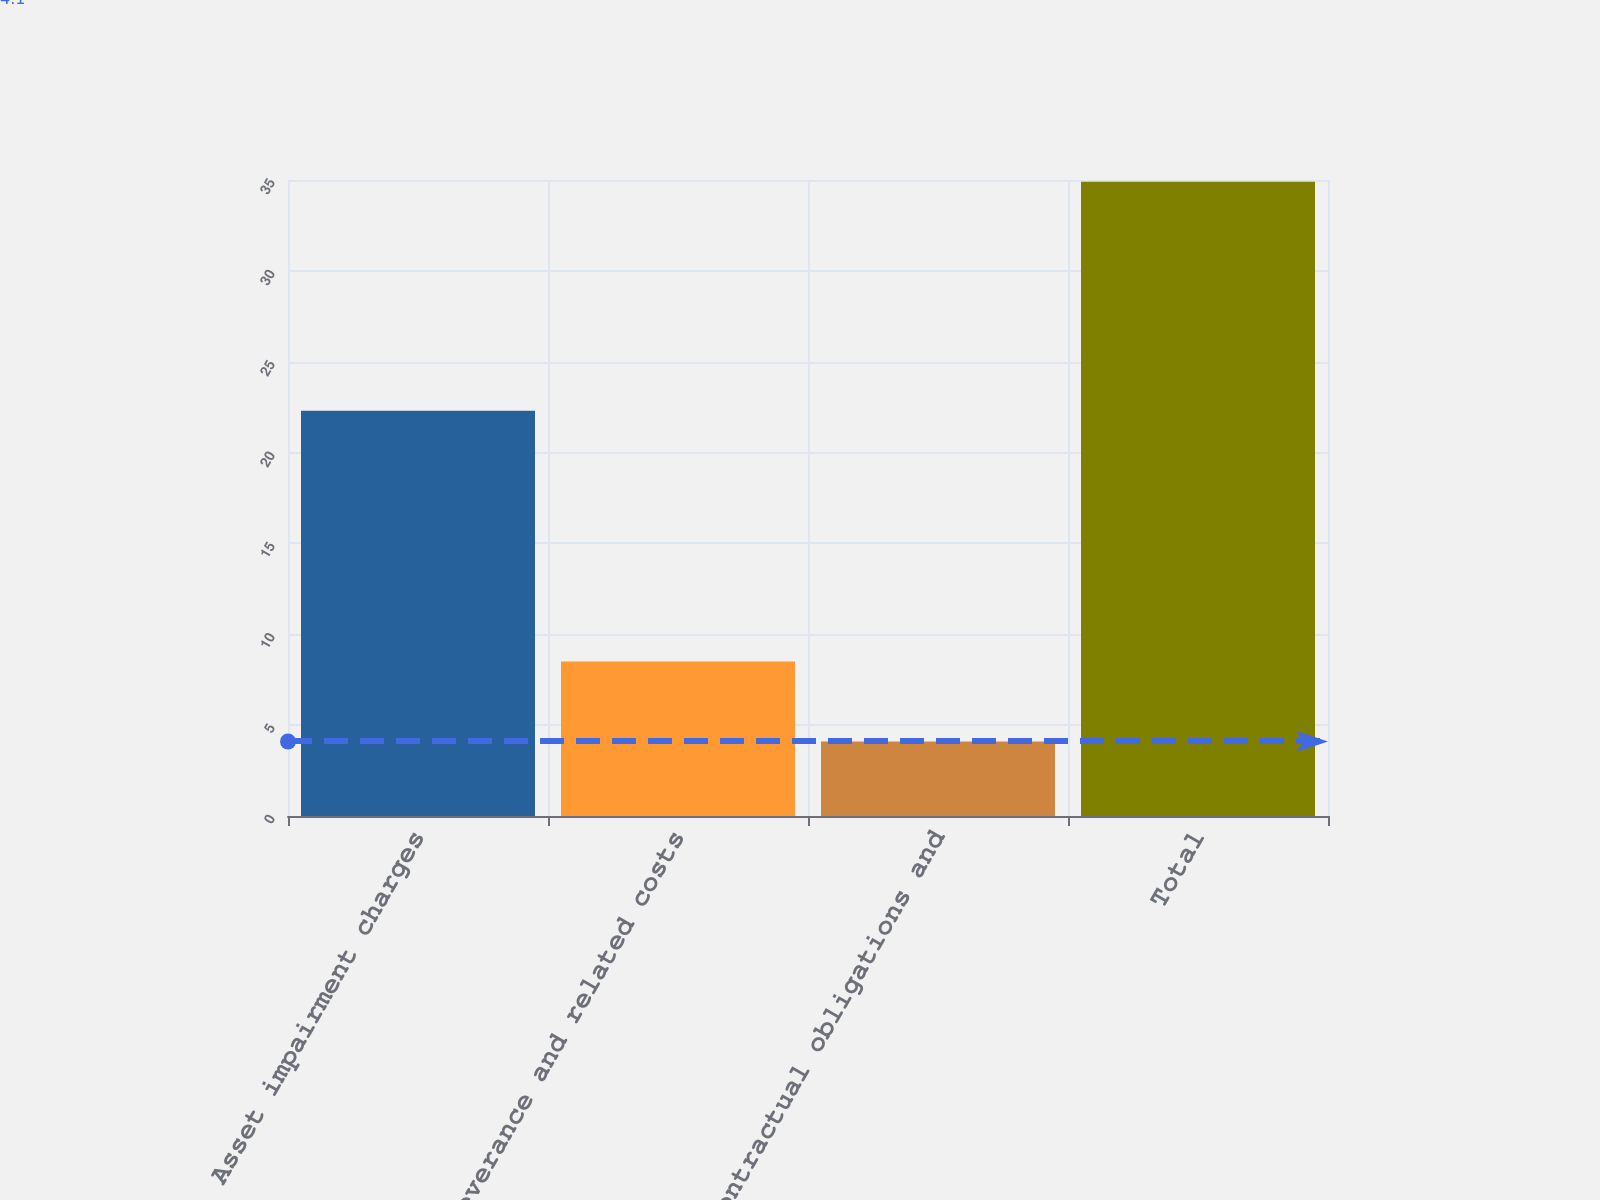Convert chart. <chart><loc_0><loc_0><loc_500><loc_500><bar_chart><fcel>Asset impairment charges<fcel>Severance and related costs<fcel>Contractual obligations and<fcel>Total<nl><fcel>22.3<fcel>8.5<fcel>4.1<fcel>34.9<nl></chart> 